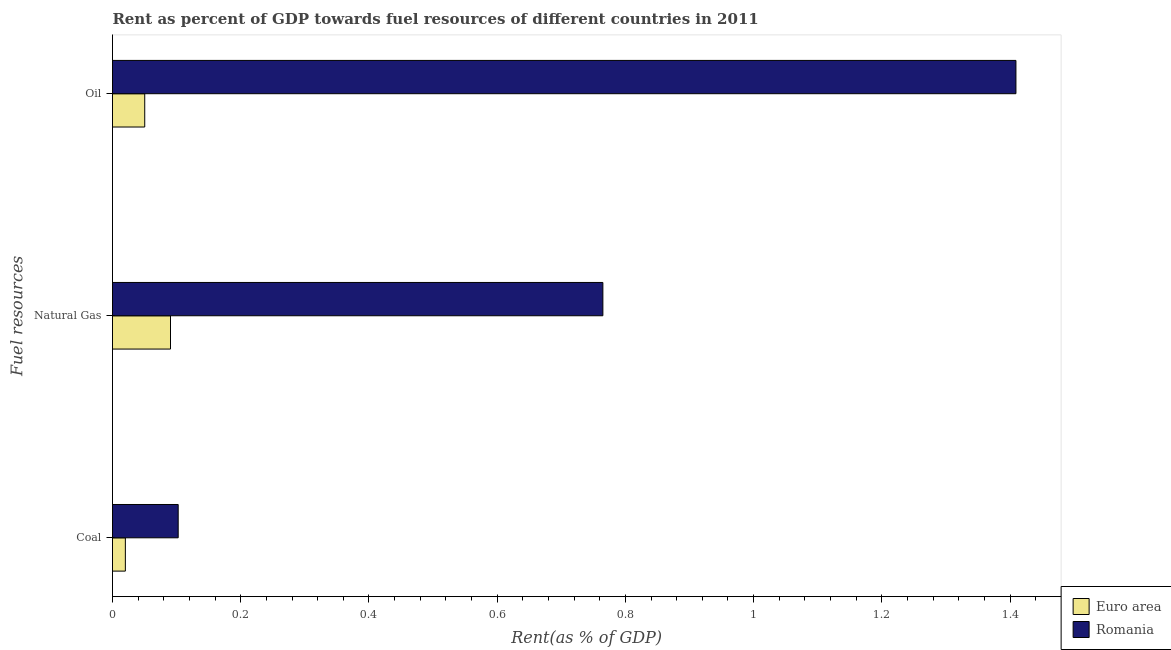How many different coloured bars are there?
Provide a succinct answer. 2. How many groups of bars are there?
Offer a terse response. 3. How many bars are there on the 3rd tick from the bottom?
Offer a very short reply. 2. What is the label of the 3rd group of bars from the top?
Give a very brief answer. Coal. What is the rent towards coal in Romania?
Offer a very short reply. 0.1. Across all countries, what is the maximum rent towards oil?
Offer a terse response. 1.41. Across all countries, what is the minimum rent towards oil?
Give a very brief answer. 0.05. In which country was the rent towards natural gas maximum?
Your answer should be compact. Romania. In which country was the rent towards oil minimum?
Offer a terse response. Euro area. What is the total rent towards oil in the graph?
Provide a short and direct response. 1.46. What is the difference between the rent towards coal in Euro area and that in Romania?
Keep it short and to the point. -0.08. What is the difference between the rent towards coal in Romania and the rent towards natural gas in Euro area?
Provide a succinct answer. 0.01. What is the average rent towards oil per country?
Your answer should be very brief. 0.73. What is the difference between the rent towards natural gas and rent towards coal in Romania?
Provide a short and direct response. 0.66. What is the ratio of the rent towards natural gas in Euro area to that in Romania?
Your answer should be very brief. 0.12. Is the rent towards natural gas in Euro area less than that in Romania?
Provide a short and direct response. Yes. What is the difference between the highest and the second highest rent towards coal?
Give a very brief answer. 0.08. What is the difference between the highest and the lowest rent towards natural gas?
Offer a terse response. 0.67. In how many countries, is the rent towards natural gas greater than the average rent towards natural gas taken over all countries?
Your answer should be very brief. 1. What does the 2nd bar from the top in Coal represents?
Your answer should be compact. Euro area. What does the 1st bar from the bottom in Coal represents?
Keep it short and to the point. Euro area. Is it the case that in every country, the sum of the rent towards coal and rent towards natural gas is greater than the rent towards oil?
Your response must be concise. No. Are the values on the major ticks of X-axis written in scientific E-notation?
Offer a very short reply. No. Does the graph contain any zero values?
Your answer should be very brief. No. Where does the legend appear in the graph?
Keep it short and to the point. Bottom right. How many legend labels are there?
Offer a terse response. 2. How are the legend labels stacked?
Offer a terse response. Vertical. What is the title of the graph?
Keep it short and to the point. Rent as percent of GDP towards fuel resources of different countries in 2011. What is the label or title of the X-axis?
Your answer should be very brief. Rent(as % of GDP). What is the label or title of the Y-axis?
Make the answer very short. Fuel resources. What is the Rent(as % of GDP) in Euro area in Coal?
Provide a short and direct response. 0.02. What is the Rent(as % of GDP) in Romania in Coal?
Give a very brief answer. 0.1. What is the Rent(as % of GDP) in Euro area in Natural Gas?
Your response must be concise. 0.09. What is the Rent(as % of GDP) in Romania in Natural Gas?
Your answer should be compact. 0.76. What is the Rent(as % of GDP) of Euro area in Oil?
Ensure brevity in your answer.  0.05. What is the Rent(as % of GDP) of Romania in Oil?
Your answer should be compact. 1.41. Across all Fuel resources, what is the maximum Rent(as % of GDP) of Euro area?
Offer a terse response. 0.09. Across all Fuel resources, what is the maximum Rent(as % of GDP) in Romania?
Make the answer very short. 1.41. Across all Fuel resources, what is the minimum Rent(as % of GDP) of Euro area?
Provide a short and direct response. 0.02. Across all Fuel resources, what is the minimum Rent(as % of GDP) in Romania?
Your answer should be compact. 0.1. What is the total Rent(as % of GDP) in Euro area in the graph?
Ensure brevity in your answer.  0.16. What is the total Rent(as % of GDP) in Romania in the graph?
Provide a short and direct response. 2.28. What is the difference between the Rent(as % of GDP) of Euro area in Coal and that in Natural Gas?
Ensure brevity in your answer.  -0.07. What is the difference between the Rent(as % of GDP) of Romania in Coal and that in Natural Gas?
Your answer should be compact. -0.66. What is the difference between the Rent(as % of GDP) in Euro area in Coal and that in Oil?
Your response must be concise. -0.03. What is the difference between the Rent(as % of GDP) in Romania in Coal and that in Oil?
Your answer should be compact. -1.31. What is the difference between the Rent(as % of GDP) of Euro area in Natural Gas and that in Oil?
Make the answer very short. 0.04. What is the difference between the Rent(as % of GDP) in Romania in Natural Gas and that in Oil?
Your answer should be compact. -0.64. What is the difference between the Rent(as % of GDP) in Euro area in Coal and the Rent(as % of GDP) in Romania in Natural Gas?
Provide a short and direct response. -0.74. What is the difference between the Rent(as % of GDP) of Euro area in Coal and the Rent(as % of GDP) of Romania in Oil?
Ensure brevity in your answer.  -1.39. What is the difference between the Rent(as % of GDP) of Euro area in Natural Gas and the Rent(as % of GDP) of Romania in Oil?
Offer a terse response. -1.32. What is the average Rent(as % of GDP) of Euro area per Fuel resources?
Ensure brevity in your answer.  0.05. What is the average Rent(as % of GDP) in Romania per Fuel resources?
Make the answer very short. 0.76. What is the difference between the Rent(as % of GDP) in Euro area and Rent(as % of GDP) in Romania in Coal?
Give a very brief answer. -0.08. What is the difference between the Rent(as % of GDP) in Euro area and Rent(as % of GDP) in Romania in Natural Gas?
Offer a very short reply. -0.67. What is the difference between the Rent(as % of GDP) in Euro area and Rent(as % of GDP) in Romania in Oil?
Offer a very short reply. -1.36. What is the ratio of the Rent(as % of GDP) in Euro area in Coal to that in Natural Gas?
Make the answer very short. 0.22. What is the ratio of the Rent(as % of GDP) of Romania in Coal to that in Natural Gas?
Offer a terse response. 0.13. What is the ratio of the Rent(as % of GDP) in Euro area in Coal to that in Oil?
Your response must be concise. 0.4. What is the ratio of the Rent(as % of GDP) in Romania in Coal to that in Oil?
Offer a very short reply. 0.07. What is the ratio of the Rent(as % of GDP) in Euro area in Natural Gas to that in Oil?
Your answer should be very brief. 1.8. What is the ratio of the Rent(as % of GDP) in Romania in Natural Gas to that in Oil?
Your answer should be compact. 0.54. What is the difference between the highest and the second highest Rent(as % of GDP) of Euro area?
Give a very brief answer. 0.04. What is the difference between the highest and the second highest Rent(as % of GDP) in Romania?
Give a very brief answer. 0.64. What is the difference between the highest and the lowest Rent(as % of GDP) in Euro area?
Your answer should be very brief. 0.07. What is the difference between the highest and the lowest Rent(as % of GDP) in Romania?
Keep it short and to the point. 1.31. 